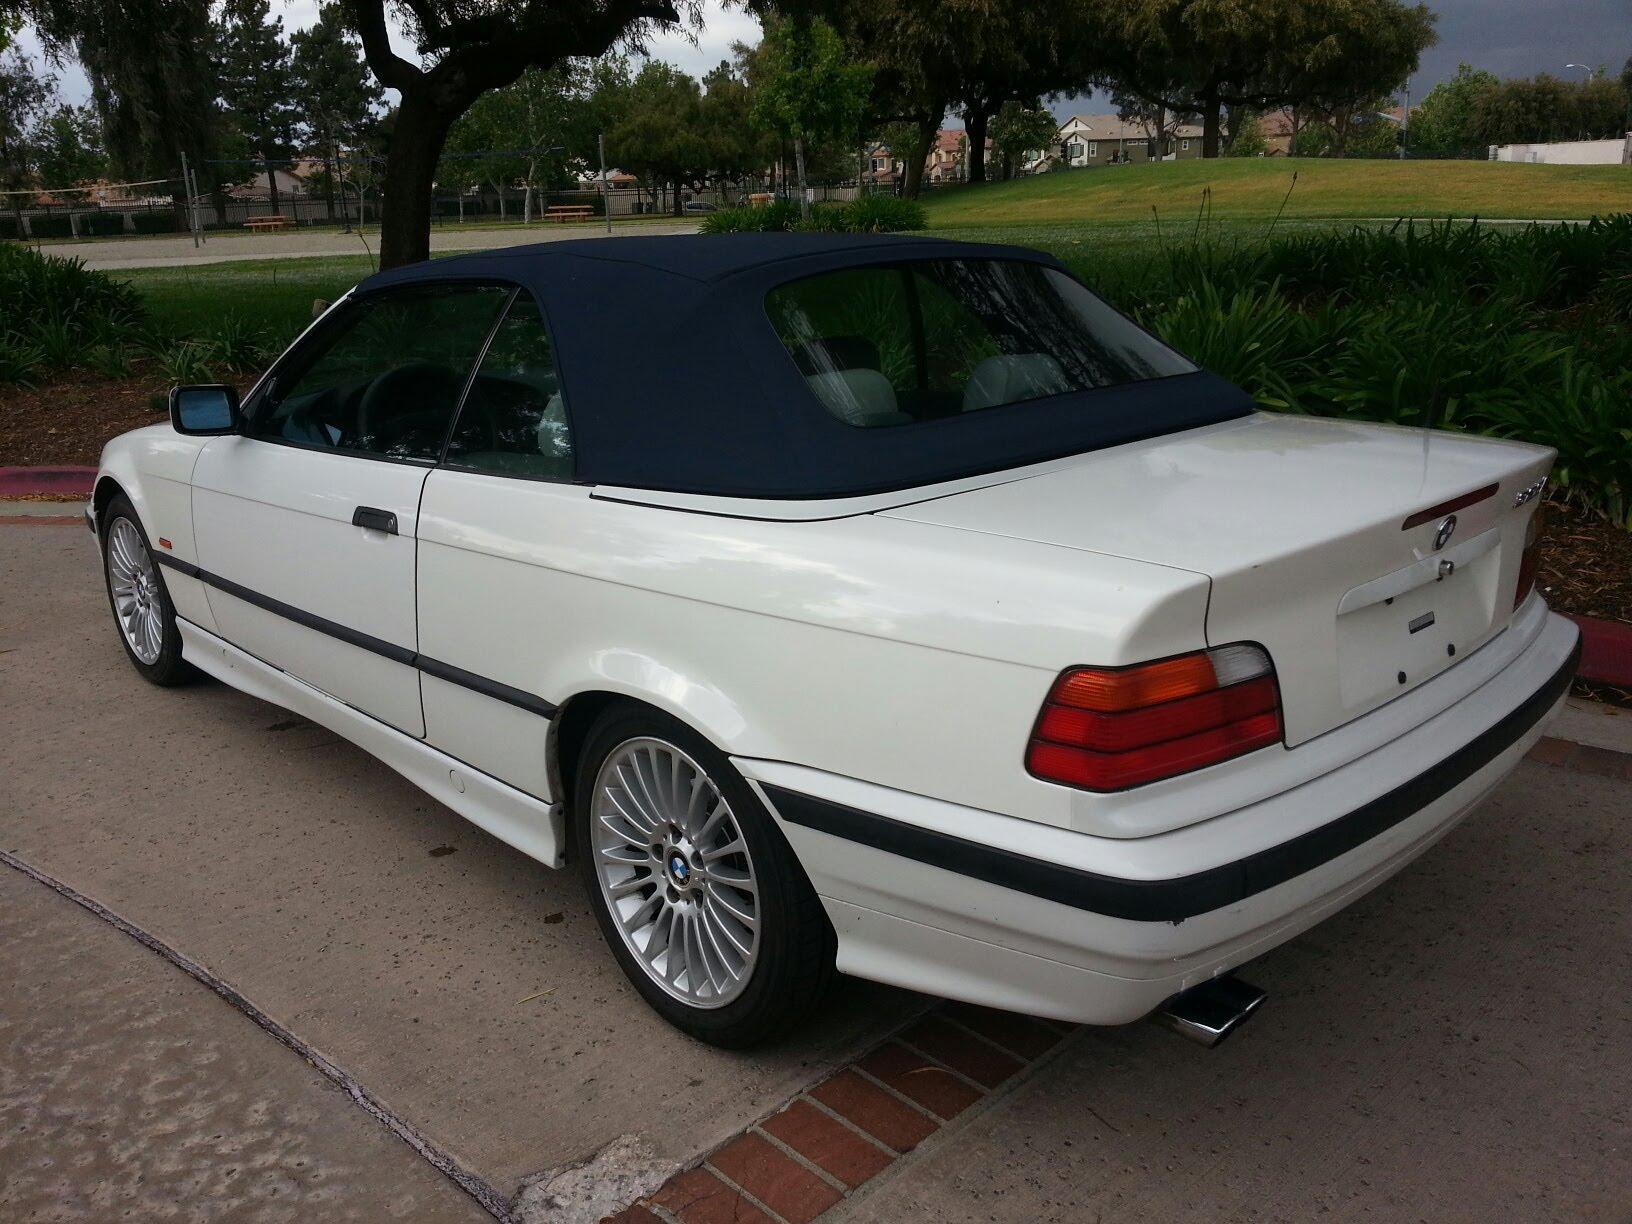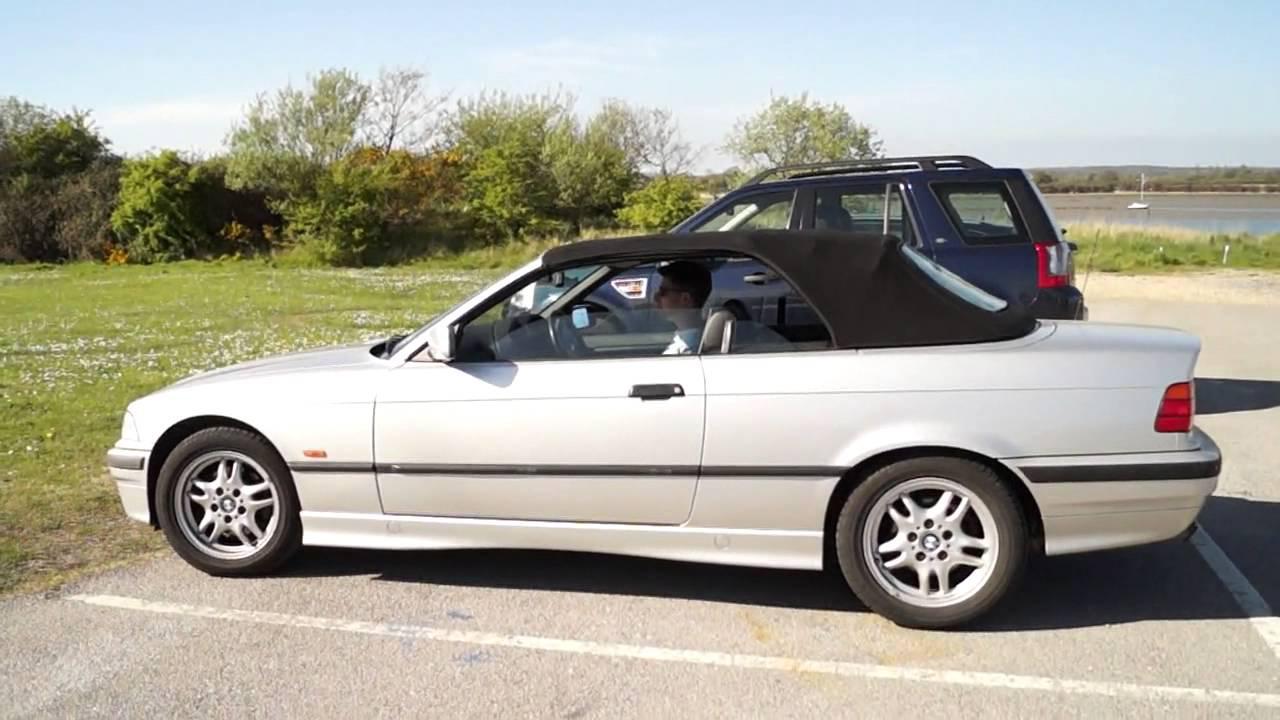The first image is the image on the left, the second image is the image on the right. Assess this claim about the two images: "The car in the right image is facing towards the right.". Correct or not? Answer yes or no. No. The first image is the image on the left, the second image is the image on the right. Analyze the images presented: Is the assertion "There are two cars, but only one roof." valid? Answer yes or no. No. 